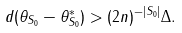<formula> <loc_0><loc_0><loc_500><loc_500>d ( \theta _ { S _ { 0 } } - \theta ^ { * } _ { S _ { 0 } } ) > ( 2 n ) ^ { - | S _ { 0 } | } \Delta .</formula> 